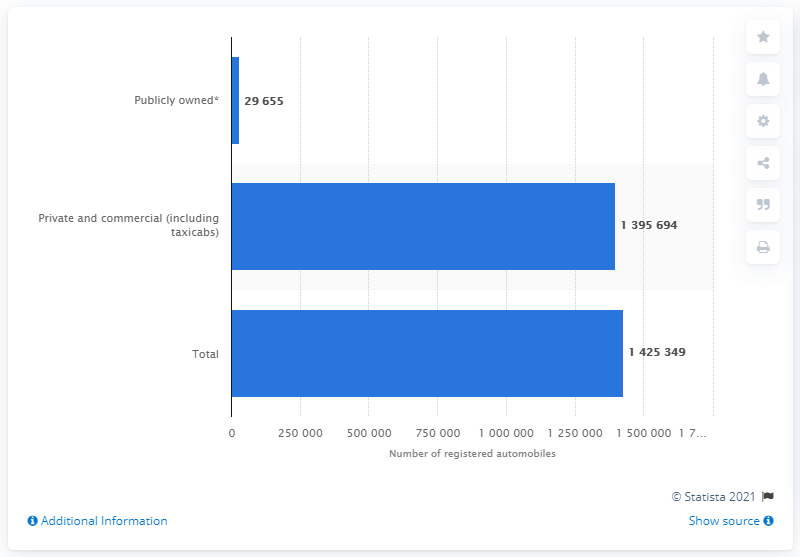Indicate a few pertinent items in this graphic. In 2016, a total of 139,5694 private and commercial automobiles were registered in the state of Louisiana. 